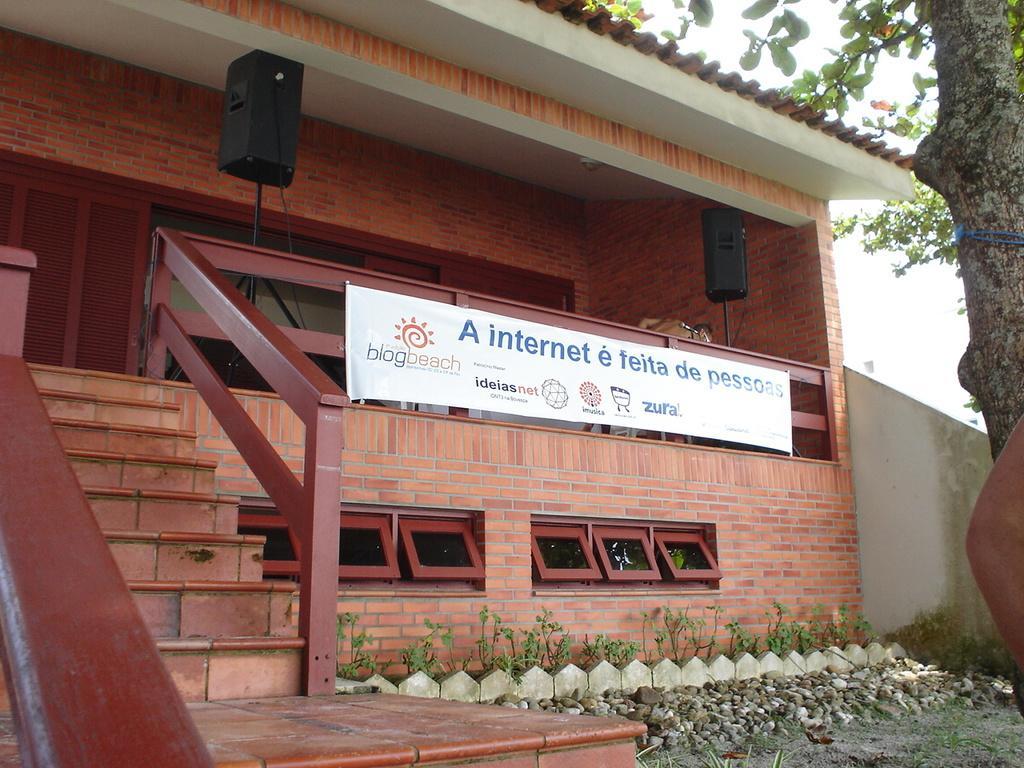Could you give a brief overview of what you see in this image? As we can see in the image there is a house, stairs, stones, plants, banner, sound box and a tree. 